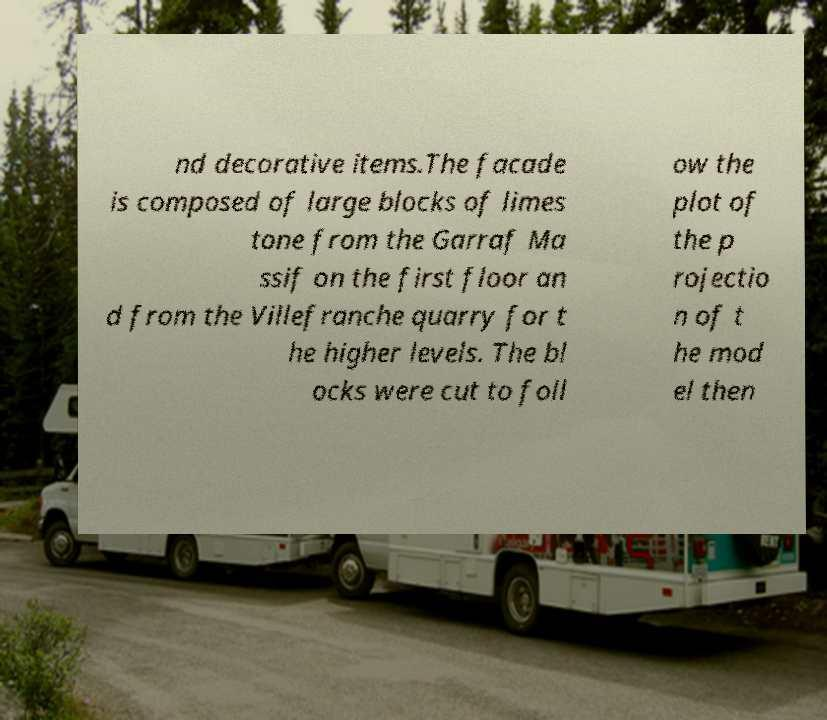For documentation purposes, I need the text within this image transcribed. Could you provide that? nd decorative items.The facade is composed of large blocks of limes tone from the Garraf Ma ssif on the first floor an d from the Villefranche quarry for t he higher levels. The bl ocks were cut to foll ow the plot of the p rojectio n of t he mod el then 